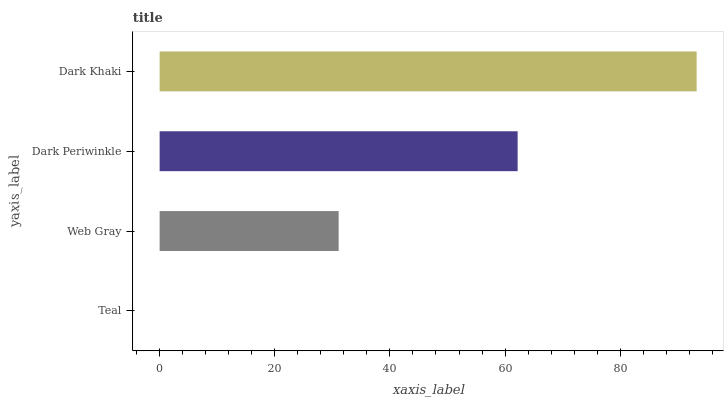Is Teal the minimum?
Answer yes or no. Yes. Is Dark Khaki the maximum?
Answer yes or no. Yes. Is Web Gray the minimum?
Answer yes or no. No. Is Web Gray the maximum?
Answer yes or no. No. Is Web Gray greater than Teal?
Answer yes or no. Yes. Is Teal less than Web Gray?
Answer yes or no. Yes. Is Teal greater than Web Gray?
Answer yes or no. No. Is Web Gray less than Teal?
Answer yes or no. No. Is Dark Periwinkle the high median?
Answer yes or no. Yes. Is Web Gray the low median?
Answer yes or no. Yes. Is Teal the high median?
Answer yes or no. No. Is Teal the low median?
Answer yes or no. No. 